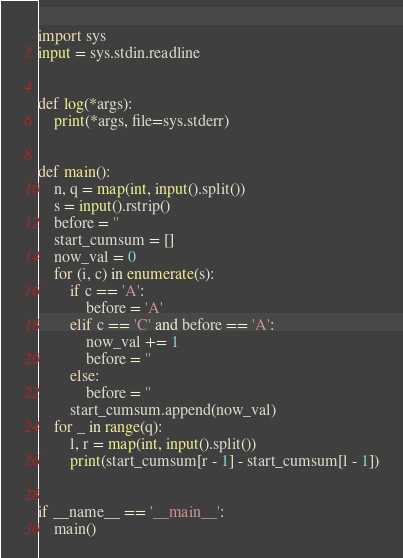Convert code to text. <code><loc_0><loc_0><loc_500><loc_500><_Python_>import sys
input = sys.stdin.readline


def log(*args):
    print(*args, file=sys.stderr)


def main():
    n, q = map(int, input().split())
    s = input().rstrip()
    before = ''
    start_cumsum = []
    now_val = 0
    for (i, c) in enumerate(s):
        if c == 'A':
            before = 'A'
        elif c == 'C' and before == 'A':
            now_val += 1
            before = ''
        else:
            before = ''
        start_cumsum.append(now_val)
    for _ in range(q):
        l, r = map(int, input().split())
        print(start_cumsum[r - 1] - start_cumsum[l - 1])


if __name__ == '__main__':
    main()
</code> 